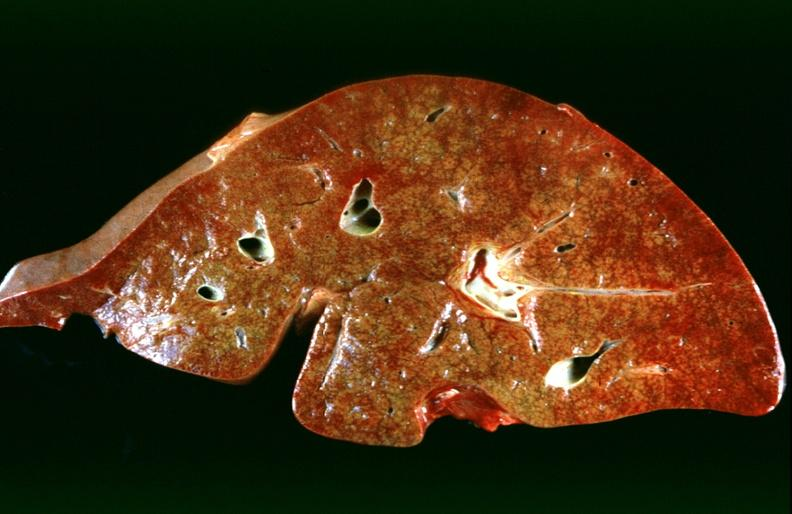what does this image show?
Answer the question using a single word or phrase. Hepatic congestion due to congestive heart failure 